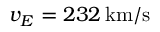Convert formula to latex. <formula><loc_0><loc_0><loc_500><loc_500>v _ { E } = 2 3 2 \, k m / s</formula> 